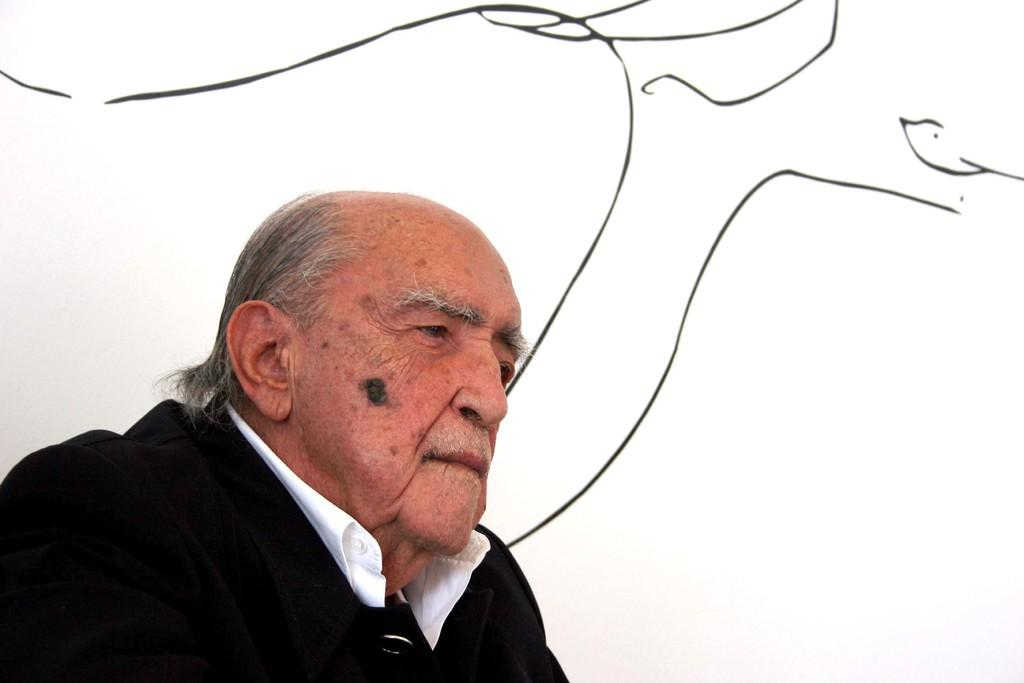Who is present in the image? There is a man in the image. What can be seen in the background of the image? There is a white surface in the background of the image. Can you describe the white surface in more detail? The white surface appears to be a wall with art. What month is depicted in the art on the wall? There is no indication of a specific month in the art on the wall, as the image only shows a man and a white surface with art. 